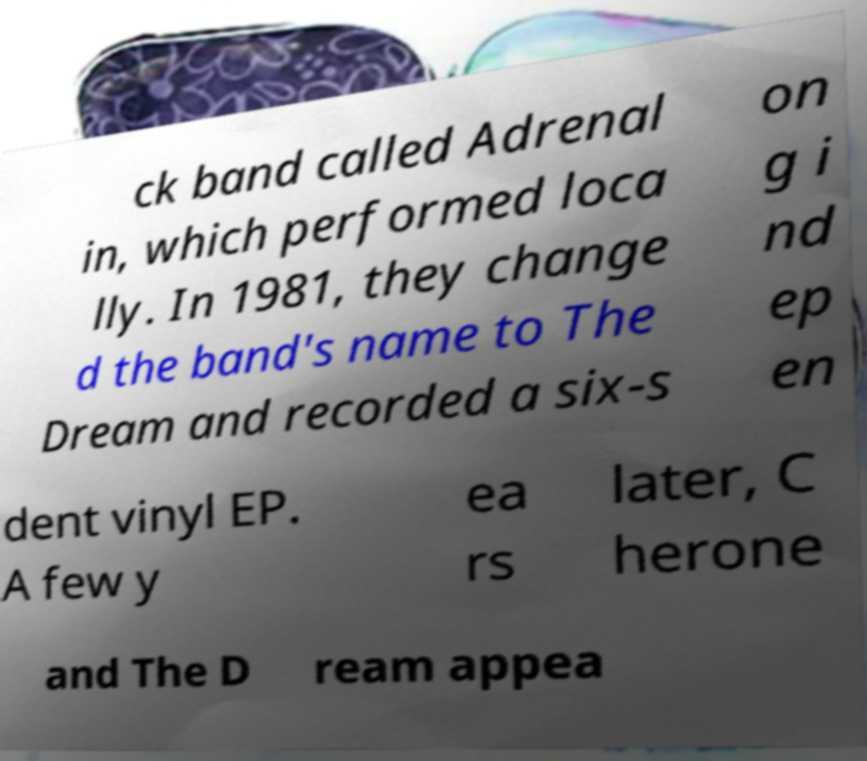Could you extract and type out the text from this image? ck band called Adrenal in, which performed loca lly. In 1981, they change d the band's name to The Dream and recorded a six-s on g i nd ep en dent vinyl EP. A few y ea rs later, C herone and The D ream appea 